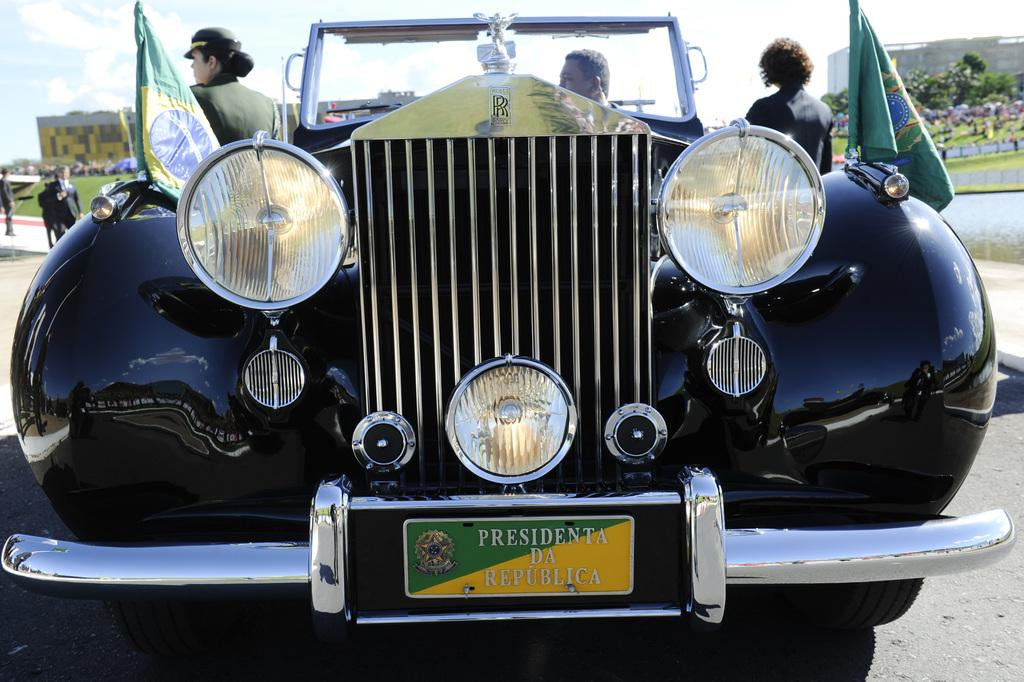What is the main subject of the image? There is a car in the image. Can you describe the people in the background? There are two persons standing in the background, one on the left and one on the right. What is attached to the car? There are two flags attached to the car. What can be seen in the background of the image? There is a building and a tree visible in the background. What type of owl can be seen perched on the wire in the image? There is no owl or wire present in the image. What is the car using to support its weight in the image? The car is not using a beam to support its weight in the image; it is resting on the ground. 